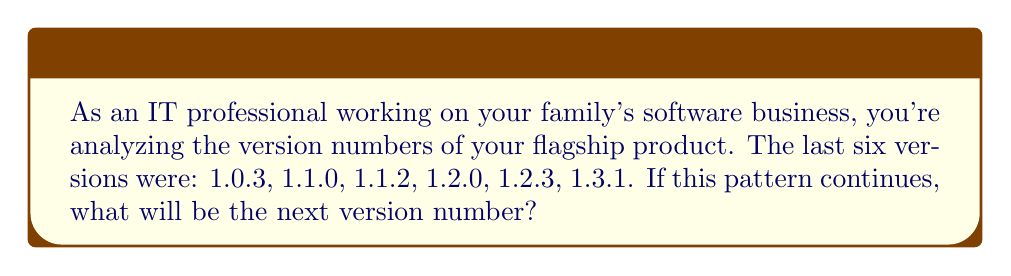Can you solve this math problem? Let's break down the version numbers and analyze the pattern:

1. The version numbers follow the format $x.y.z$, where:
   $x$ = major version
   $y$ = minor version
   $z$ = patch version

2. Observing the sequence:
   1.0.3 → 1.1.0 → 1.1.2 → 1.2.0 → 1.2.3 → 1.3.1

3. Pattern analysis:
   a) The major version ($x$) remains constant at 1.
   b) The minor version ($y$) increments by 1 every two or three releases.
   c) The patch version ($z$) follows a pattern: 3 → 0 → 2 → 0 → 3 → 1

4. To predict the next version:
   a) Major version will stay at 1.
   b) Minor version just increased to 3, so it will likely stay at 3.
   c) The patch version should follow the observed pattern.

5. The next number in the patch version sequence (3, 0, 2, 0, 3, 1, ?) would be 4.

Therefore, the next version number in the sequence will be 1.3.4.
Answer: 1.3.4 